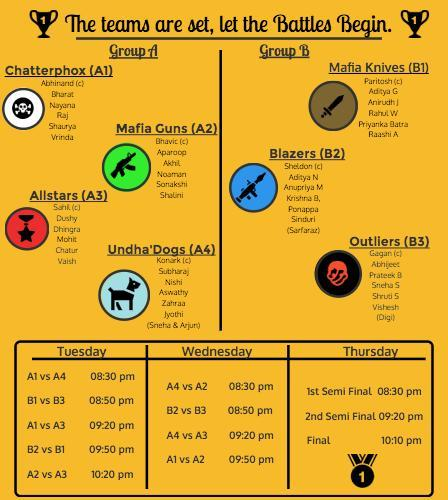Wdich teams will be playing the third match on Wednesday
Answer the question with a short phrase. A4 vs A3 What number is written on the medal 1 Priyanka Batra is in which team Mafia Knives Who is the captain of Undha Dogs Konark How many members in Allstars 6 How many matches on Tuesday 5 What time is the third match on Thursday 10:10 pm Sonakshi belongs to which team Mafia Guns 